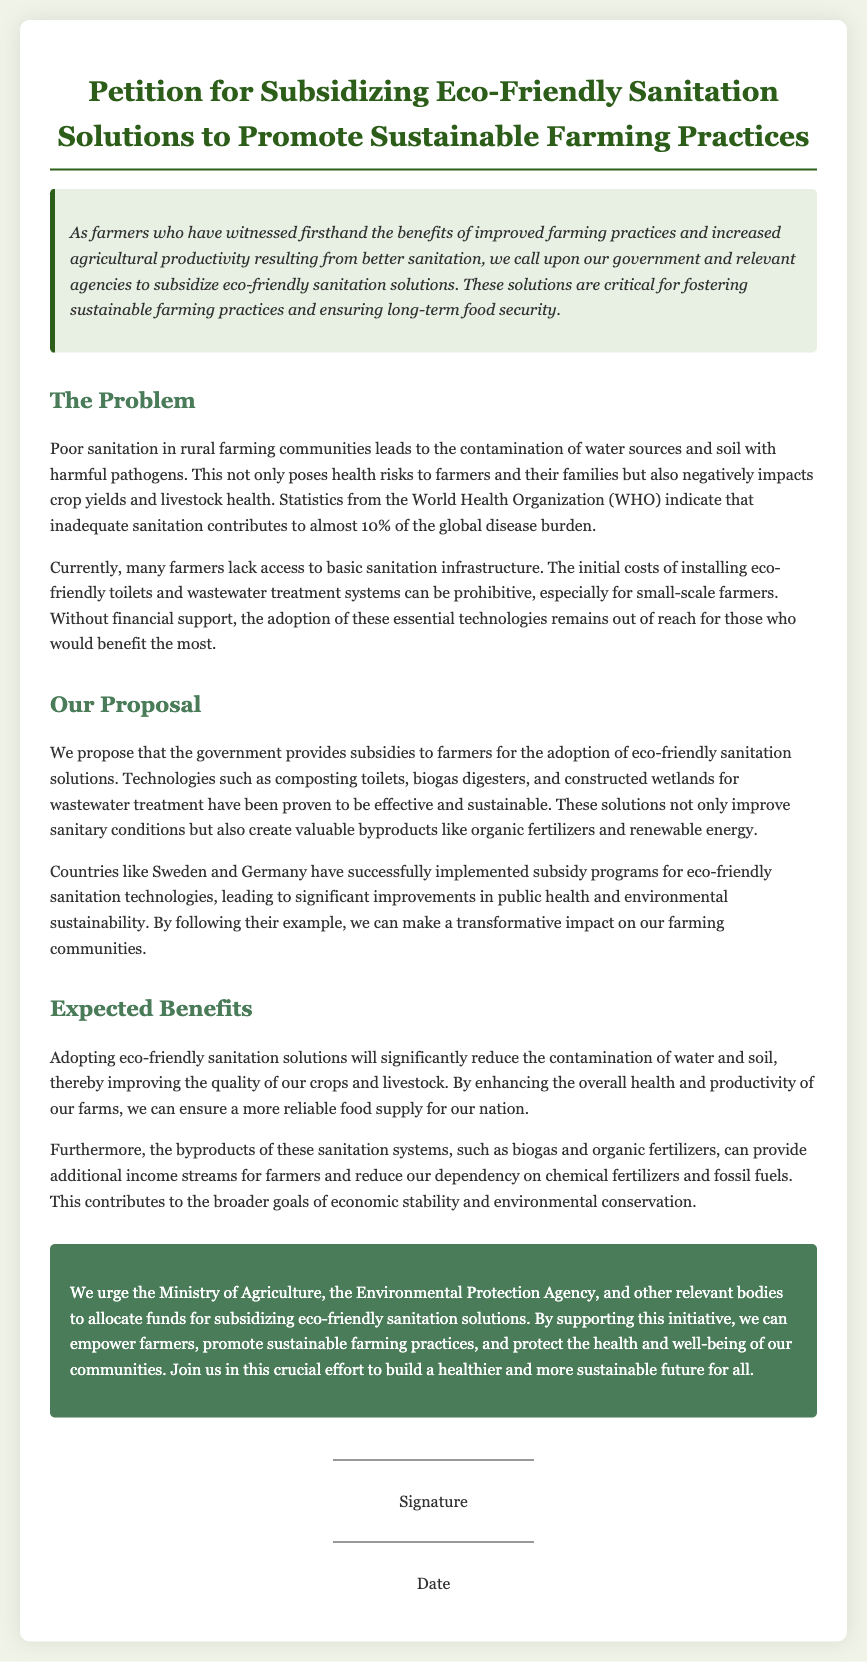What is the title of the petition? The title is explicitly stated at the beginning of the document.
Answer: Petition for Subsidizing Eco-Friendly Sanitation Solutions to Promote Sustainable Farming Practices What is the main problem addressed in the petition? The problem is described in the section where it discusses sanitation issues in rural communities.
Answer: Poor sanitation What percentage of the global disease burden is attributed to inadequate sanitation? This statistic is mentioned in the problem section of the document.
Answer: Almost 10% What technology is proposed for subsidization? The document lists specific technologies that farmers can adopt for sanitation improvement.
Answer: Composting toilets Which two countries are mentioned as examples of successful subsidy programs? The petition explicitly references these countries to illustrate successful implementations.
Answer: Sweden and Germany What are the expected benefits of adopting eco-friendly sanitation solutions? The benefits are outlined in the section discussing the impacts of the proposed solutions.
Answer: Improved health and productivity Who is the call to action directed at? The document specifies which governmental bodies the petition addresses for support.
Answer: Ministry of Agriculture, Environmental Protection Agency What is one byproduct of eco-friendly sanitation solutions? The document mentions specific advantages of adopting these systems.
Answer: Biogas 